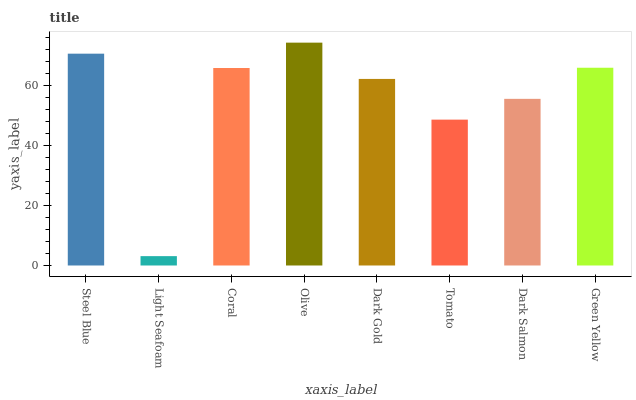Is Light Seafoam the minimum?
Answer yes or no. Yes. Is Olive the maximum?
Answer yes or no. Yes. Is Coral the minimum?
Answer yes or no. No. Is Coral the maximum?
Answer yes or no. No. Is Coral greater than Light Seafoam?
Answer yes or no. Yes. Is Light Seafoam less than Coral?
Answer yes or no. Yes. Is Light Seafoam greater than Coral?
Answer yes or no. No. Is Coral less than Light Seafoam?
Answer yes or no. No. Is Coral the high median?
Answer yes or no. Yes. Is Dark Gold the low median?
Answer yes or no. Yes. Is Dark Gold the high median?
Answer yes or no. No. Is Dark Salmon the low median?
Answer yes or no. No. 